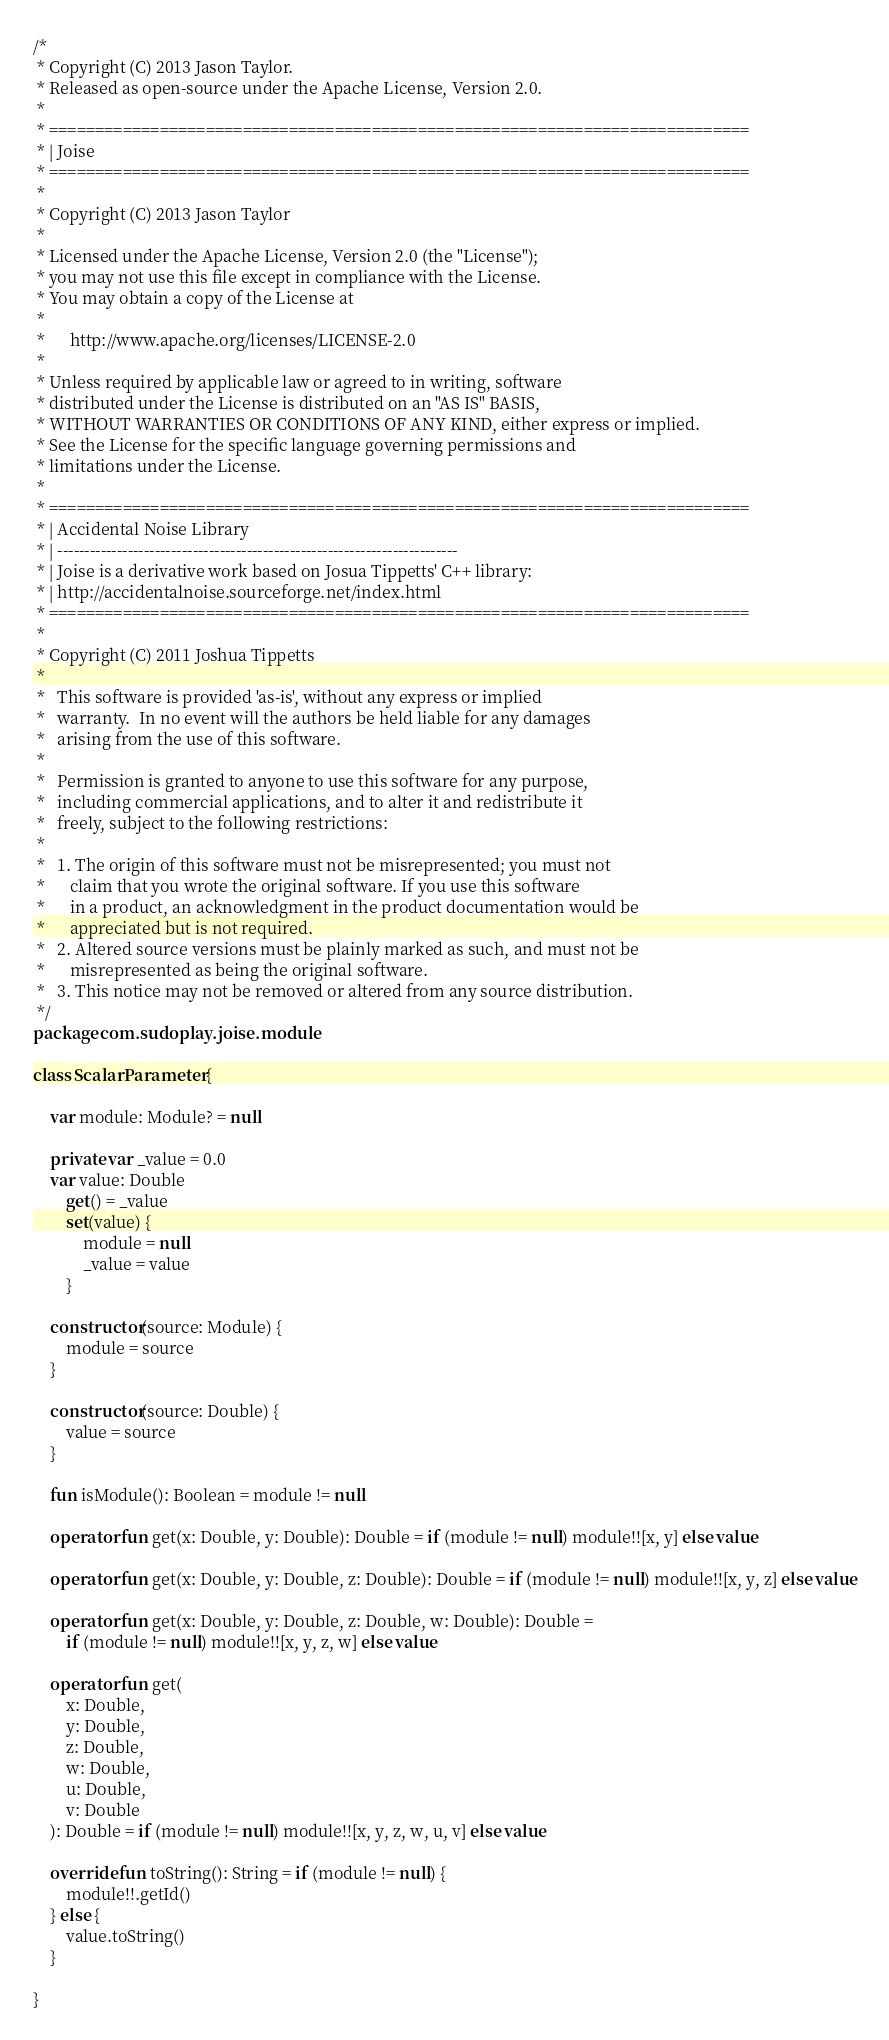Convert code to text. <code><loc_0><loc_0><loc_500><loc_500><_Kotlin_>/*
 * Copyright (C) 2013 Jason Taylor.
 * Released as open-source under the Apache License, Version 2.0.
 *
 * ============================================================================
 * | Joise
 * ============================================================================
 *
 * Copyright (C) 2013 Jason Taylor
 *
 * Licensed under the Apache License, Version 2.0 (the "License");
 * you may not use this file except in compliance with the License.
 * You may obtain a copy of the License at
 *
 *      http://www.apache.org/licenses/LICENSE-2.0
 *
 * Unless required by applicable law or agreed to in writing, software
 * distributed under the License is distributed on an "AS IS" BASIS,
 * WITHOUT WARRANTIES OR CONDITIONS OF ANY KIND, either express or implied.
 * See the License for the specific language governing permissions and
 * limitations under the License.
 *
 * ============================================================================
 * | Accidental Noise Library
 * | --------------------------------------------------------------------------
 * | Joise is a derivative work based on Josua Tippetts' C++ library:
 * | http://accidentalnoise.sourceforge.net/index.html
 * ============================================================================
 *
 * Copyright (C) 2011 Joshua Tippetts
 *
 *   This software is provided 'as-is', without any express or implied
 *   warranty.  In no event will the authors be held liable for any damages
 *   arising from the use of this software.
 *
 *   Permission is granted to anyone to use this software for any purpose,
 *   including commercial applications, and to alter it and redistribute it
 *   freely, subject to the following restrictions:
 *
 *   1. The origin of this software must not be misrepresented; you must not
 *      claim that you wrote the original software. If you use this software
 *      in a product, an acknowledgment in the product documentation would be
 *      appreciated but is not required.
 *   2. Altered source versions must be plainly marked as such, and must not be
 *      misrepresented as being the original software.
 *   3. This notice may not be removed or altered from any source distribution.
 */
package com.sudoplay.joise.module

class ScalarParameter {

    var module: Module? = null

    private var _value = 0.0
    var value: Double
        get() = _value
        set(value) {
            module = null
            _value = value
        }

    constructor(source: Module) {
        module = source
    }

    constructor(source: Double) {
        value = source
    }

    fun isModule(): Boolean = module != null

    operator fun get(x: Double, y: Double): Double = if (module != null) module!![x, y] else value

    operator fun get(x: Double, y: Double, z: Double): Double = if (module != null) module!![x, y, z] else value

    operator fun get(x: Double, y: Double, z: Double, w: Double): Double =
        if (module != null) module!![x, y, z, w] else value

    operator fun get(
        x: Double,
        y: Double,
        z: Double,
        w: Double,
        u: Double,
        v: Double
    ): Double = if (module != null) module!![x, y, z, w, u, v] else value

    override fun toString(): String = if (module != null) {
        module!!.getId()
    } else {
        value.toString()
    }

}
</code> 